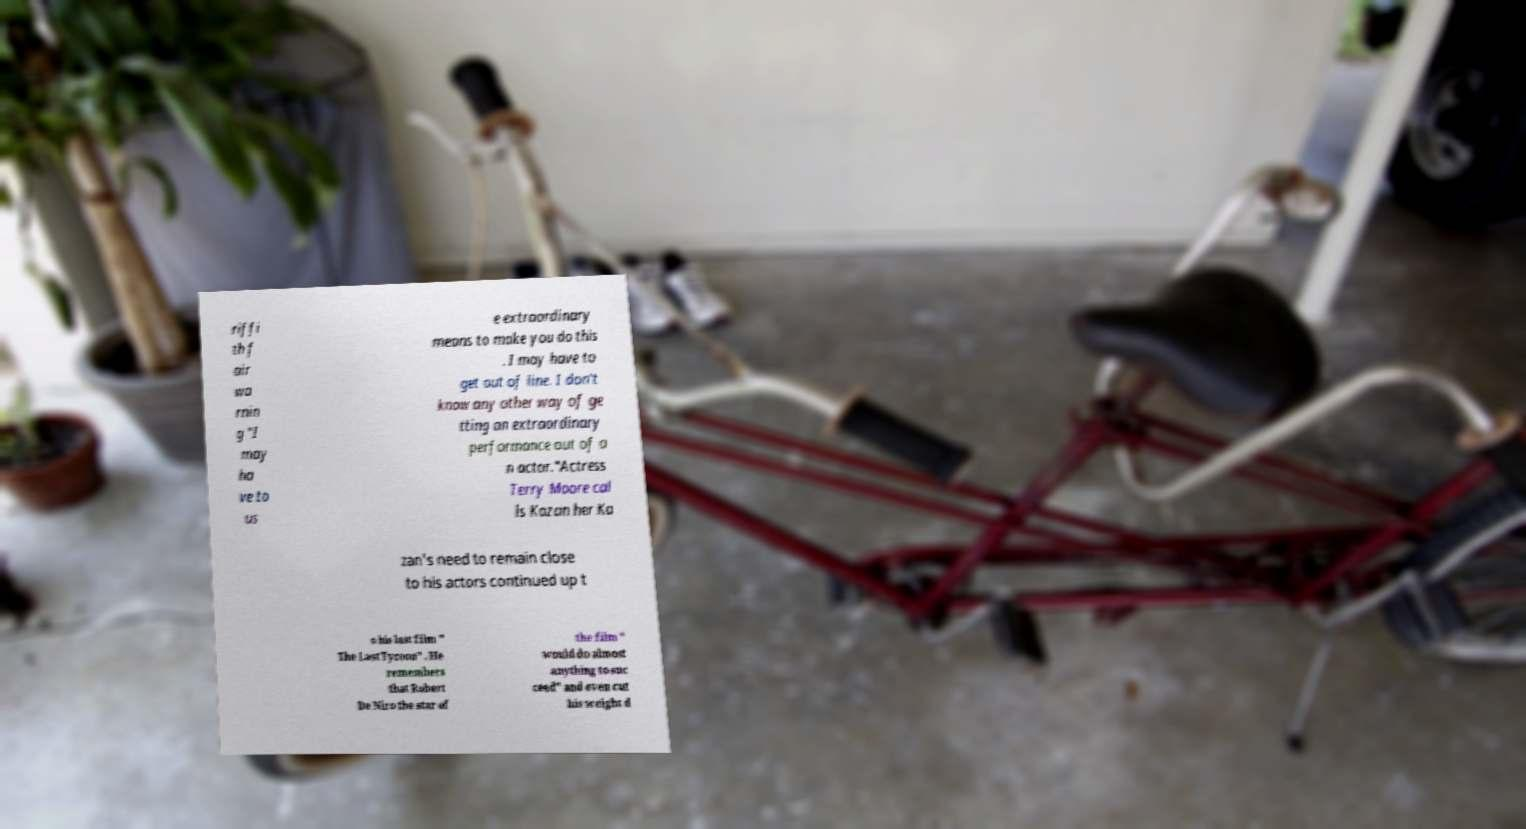Please read and relay the text visible in this image. What does it say? riffi th f air wa rnin g "I may ha ve to us e extraordinary means to make you do this . I may have to get out of line. I don't know any other way of ge tting an extraordinary performance out of a n actor."Actress Terry Moore cal ls Kazan her Ka zan's need to remain close to his actors continued up t o his last film " The Last Tycoon" . He remembers that Robert De Niro the star of the film " would do almost anything to suc ceed" and even cut his weight d 